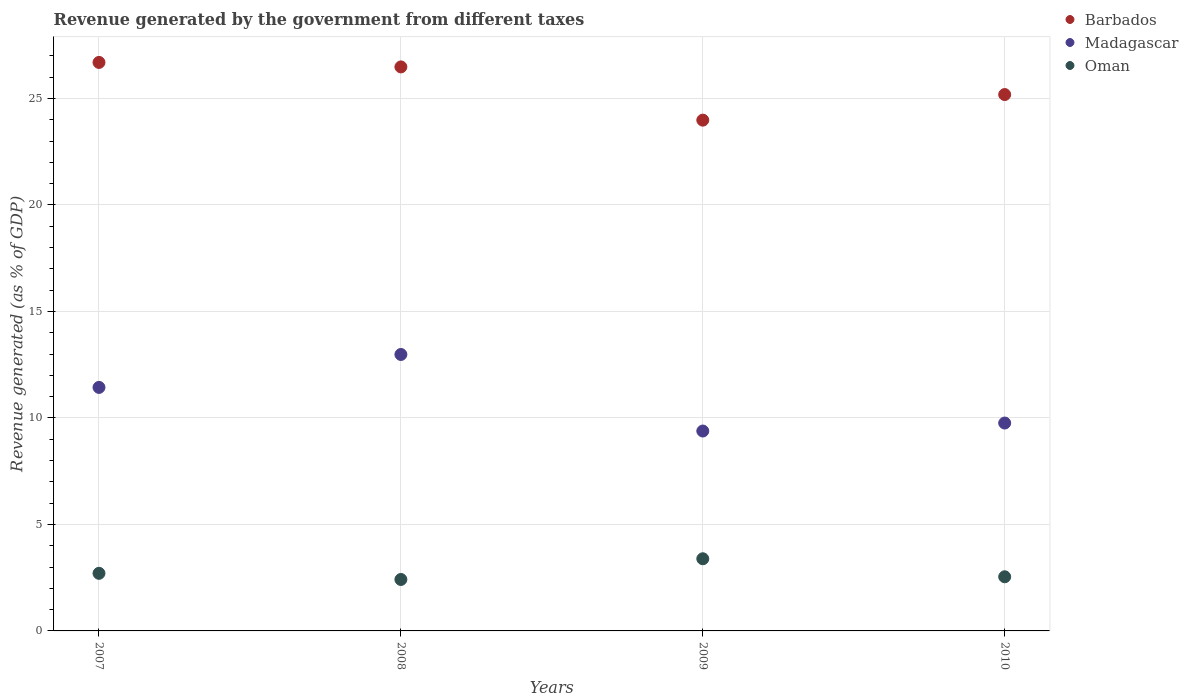How many different coloured dotlines are there?
Offer a very short reply. 3. Is the number of dotlines equal to the number of legend labels?
Offer a very short reply. Yes. What is the revenue generated by the government in Madagascar in 2007?
Your answer should be compact. 11.43. Across all years, what is the maximum revenue generated by the government in Oman?
Ensure brevity in your answer.  3.39. Across all years, what is the minimum revenue generated by the government in Barbados?
Provide a succinct answer. 23.98. In which year was the revenue generated by the government in Barbados maximum?
Provide a succinct answer. 2007. What is the total revenue generated by the government in Oman in the graph?
Provide a short and direct response. 11.05. What is the difference between the revenue generated by the government in Oman in 2008 and that in 2010?
Your answer should be compact. -0.13. What is the difference between the revenue generated by the government in Oman in 2008 and the revenue generated by the government in Madagascar in 2007?
Offer a very short reply. -9.02. What is the average revenue generated by the government in Madagascar per year?
Offer a very short reply. 10.89. In the year 2007, what is the difference between the revenue generated by the government in Madagascar and revenue generated by the government in Oman?
Keep it short and to the point. 8.73. What is the ratio of the revenue generated by the government in Madagascar in 2008 to that in 2009?
Offer a terse response. 1.38. What is the difference between the highest and the second highest revenue generated by the government in Oman?
Your answer should be very brief. 0.68. What is the difference between the highest and the lowest revenue generated by the government in Madagascar?
Provide a succinct answer. 3.59. Is it the case that in every year, the sum of the revenue generated by the government in Barbados and revenue generated by the government in Oman  is greater than the revenue generated by the government in Madagascar?
Keep it short and to the point. Yes. Does the revenue generated by the government in Madagascar monotonically increase over the years?
Keep it short and to the point. No. Is the revenue generated by the government in Oman strictly greater than the revenue generated by the government in Barbados over the years?
Keep it short and to the point. No. How many years are there in the graph?
Make the answer very short. 4. Where does the legend appear in the graph?
Keep it short and to the point. Top right. How are the legend labels stacked?
Your response must be concise. Vertical. What is the title of the graph?
Keep it short and to the point. Revenue generated by the government from different taxes. What is the label or title of the X-axis?
Provide a succinct answer. Years. What is the label or title of the Y-axis?
Keep it short and to the point. Revenue generated (as % of GDP). What is the Revenue generated (as % of GDP) of Barbados in 2007?
Make the answer very short. 26.69. What is the Revenue generated (as % of GDP) in Madagascar in 2007?
Make the answer very short. 11.43. What is the Revenue generated (as % of GDP) of Oman in 2007?
Offer a terse response. 2.7. What is the Revenue generated (as % of GDP) of Barbados in 2008?
Provide a short and direct response. 26.48. What is the Revenue generated (as % of GDP) of Madagascar in 2008?
Your answer should be very brief. 12.98. What is the Revenue generated (as % of GDP) in Oman in 2008?
Provide a succinct answer. 2.42. What is the Revenue generated (as % of GDP) of Barbados in 2009?
Offer a terse response. 23.98. What is the Revenue generated (as % of GDP) in Madagascar in 2009?
Give a very brief answer. 9.38. What is the Revenue generated (as % of GDP) in Oman in 2009?
Provide a short and direct response. 3.39. What is the Revenue generated (as % of GDP) of Barbados in 2010?
Make the answer very short. 25.18. What is the Revenue generated (as % of GDP) of Madagascar in 2010?
Give a very brief answer. 9.76. What is the Revenue generated (as % of GDP) in Oman in 2010?
Your response must be concise. 2.54. Across all years, what is the maximum Revenue generated (as % of GDP) of Barbados?
Your answer should be compact. 26.69. Across all years, what is the maximum Revenue generated (as % of GDP) in Madagascar?
Offer a very short reply. 12.98. Across all years, what is the maximum Revenue generated (as % of GDP) of Oman?
Your answer should be compact. 3.39. Across all years, what is the minimum Revenue generated (as % of GDP) of Barbados?
Provide a succinct answer. 23.98. Across all years, what is the minimum Revenue generated (as % of GDP) of Madagascar?
Make the answer very short. 9.38. Across all years, what is the minimum Revenue generated (as % of GDP) of Oman?
Your response must be concise. 2.42. What is the total Revenue generated (as % of GDP) in Barbados in the graph?
Keep it short and to the point. 102.33. What is the total Revenue generated (as % of GDP) in Madagascar in the graph?
Make the answer very short. 43.56. What is the total Revenue generated (as % of GDP) in Oman in the graph?
Keep it short and to the point. 11.05. What is the difference between the Revenue generated (as % of GDP) in Barbados in 2007 and that in 2008?
Provide a short and direct response. 0.21. What is the difference between the Revenue generated (as % of GDP) in Madagascar in 2007 and that in 2008?
Offer a terse response. -1.55. What is the difference between the Revenue generated (as % of GDP) in Oman in 2007 and that in 2008?
Provide a short and direct response. 0.29. What is the difference between the Revenue generated (as % of GDP) in Barbados in 2007 and that in 2009?
Your answer should be very brief. 2.71. What is the difference between the Revenue generated (as % of GDP) in Madagascar in 2007 and that in 2009?
Offer a very short reply. 2.05. What is the difference between the Revenue generated (as % of GDP) of Oman in 2007 and that in 2009?
Give a very brief answer. -0.68. What is the difference between the Revenue generated (as % of GDP) in Barbados in 2007 and that in 2010?
Offer a very short reply. 1.51. What is the difference between the Revenue generated (as % of GDP) of Madagascar in 2007 and that in 2010?
Give a very brief answer. 1.67. What is the difference between the Revenue generated (as % of GDP) of Oman in 2007 and that in 2010?
Offer a terse response. 0.16. What is the difference between the Revenue generated (as % of GDP) in Barbados in 2008 and that in 2009?
Offer a very short reply. 2.5. What is the difference between the Revenue generated (as % of GDP) in Madagascar in 2008 and that in 2009?
Provide a succinct answer. 3.59. What is the difference between the Revenue generated (as % of GDP) of Oman in 2008 and that in 2009?
Your answer should be very brief. -0.97. What is the difference between the Revenue generated (as % of GDP) in Barbados in 2008 and that in 2010?
Your answer should be compact. 1.3. What is the difference between the Revenue generated (as % of GDP) in Madagascar in 2008 and that in 2010?
Give a very brief answer. 3.22. What is the difference between the Revenue generated (as % of GDP) in Oman in 2008 and that in 2010?
Give a very brief answer. -0.13. What is the difference between the Revenue generated (as % of GDP) of Barbados in 2009 and that in 2010?
Your response must be concise. -1.2. What is the difference between the Revenue generated (as % of GDP) in Madagascar in 2009 and that in 2010?
Your response must be concise. -0.38. What is the difference between the Revenue generated (as % of GDP) in Oman in 2009 and that in 2010?
Give a very brief answer. 0.85. What is the difference between the Revenue generated (as % of GDP) in Barbados in 2007 and the Revenue generated (as % of GDP) in Madagascar in 2008?
Offer a terse response. 13.71. What is the difference between the Revenue generated (as % of GDP) of Barbados in 2007 and the Revenue generated (as % of GDP) of Oman in 2008?
Keep it short and to the point. 24.28. What is the difference between the Revenue generated (as % of GDP) in Madagascar in 2007 and the Revenue generated (as % of GDP) in Oman in 2008?
Provide a short and direct response. 9.02. What is the difference between the Revenue generated (as % of GDP) in Barbados in 2007 and the Revenue generated (as % of GDP) in Madagascar in 2009?
Give a very brief answer. 17.31. What is the difference between the Revenue generated (as % of GDP) in Barbados in 2007 and the Revenue generated (as % of GDP) in Oman in 2009?
Your answer should be compact. 23.3. What is the difference between the Revenue generated (as % of GDP) in Madagascar in 2007 and the Revenue generated (as % of GDP) in Oman in 2009?
Your answer should be very brief. 8.05. What is the difference between the Revenue generated (as % of GDP) of Barbados in 2007 and the Revenue generated (as % of GDP) of Madagascar in 2010?
Offer a terse response. 16.93. What is the difference between the Revenue generated (as % of GDP) in Barbados in 2007 and the Revenue generated (as % of GDP) in Oman in 2010?
Provide a succinct answer. 24.15. What is the difference between the Revenue generated (as % of GDP) of Madagascar in 2007 and the Revenue generated (as % of GDP) of Oman in 2010?
Give a very brief answer. 8.89. What is the difference between the Revenue generated (as % of GDP) in Barbados in 2008 and the Revenue generated (as % of GDP) in Madagascar in 2009?
Offer a terse response. 17.1. What is the difference between the Revenue generated (as % of GDP) in Barbados in 2008 and the Revenue generated (as % of GDP) in Oman in 2009?
Your response must be concise. 23.09. What is the difference between the Revenue generated (as % of GDP) in Madagascar in 2008 and the Revenue generated (as % of GDP) in Oman in 2009?
Your response must be concise. 9.59. What is the difference between the Revenue generated (as % of GDP) of Barbados in 2008 and the Revenue generated (as % of GDP) of Madagascar in 2010?
Provide a short and direct response. 16.72. What is the difference between the Revenue generated (as % of GDP) of Barbados in 2008 and the Revenue generated (as % of GDP) of Oman in 2010?
Ensure brevity in your answer.  23.94. What is the difference between the Revenue generated (as % of GDP) of Madagascar in 2008 and the Revenue generated (as % of GDP) of Oman in 2010?
Provide a succinct answer. 10.44. What is the difference between the Revenue generated (as % of GDP) of Barbados in 2009 and the Revenue generated (as % of GDP) of Madagascar in 2010?
Offer a very short reply. 14.22. What is the difference between the Revenue generated (as % of GDP) of Barbados in 2009 and the Revenue generated (as % of GDP) of Oman in 2010?
Offer a very short reply. 21.44. What is the difference between the Revenue generated (as % of GDP) in Madagascar in 2009 and the Revenue generated (as % of GDP) in Oman in 2010?
Your response must be concise. 6.84. What is the average Revenue generated (as % of GDP) of Barbados per year?
Offer a very short reply. 25.58. What is the average Revenue generated (as % of GDP) of Madagascar per year?
Your answer should be very brief. 10.89. What is the average Revenue generated (as % of GDP) of Oman per year?
Offer a very short reply. 2.76. In the year 2007, what is the difference between the Revenue generated (as % of GDP) in Barbados and Revenue generated (as % of GDP) in Madagascar?
Keep it short and to the point. 15.26. In the year 2007, what is the difference between the Revenue generated (as % of GDP) in Barbados and Revenue generated (as % of GDP) in Oman?
Provide a short and direct response. 23.99. In the year 2007, what is the difference between the Revenue generated (as % of GDP) in Madagascar and Revenue generated (as % of GDP) in Oman?
Provide a short and direct response. 8.73. In the year 2008, what is the difference between the Revenue generated (as % of GDP) in Barbados and Revenue generated (as % of GDP) in Madagascar?
Offer a very short reply. 13.5. In the year 2008, what is the difference between the Revenue generated (as % of GDP) in Barbados and Revenue generated (as % of GDP) in Oman?
Ensure brevity in your answer.  24.06. In the year 2008, what is the difference between the Revenue generated (as % of GDP) of Madagascar and Revenue generated (as % of GDP) of Oman?
Offer a very short reply. 10.56. In the year 2009, what is the difference between the Revenue generated (as % of GDP) in Barbados and Revenue generated (as % of GDP) in Madagascar?
Make the answer very short. 14.6. In the year 2009, what is the difference between the Revenue generated (as % of GDP) in Barbados and Revenue generated (as % of GDP) in Oman?
Make the answer very short. 20.59. In the year 2009, what is the difference between the Revenue generated (as % of GDP) in Madagascar and Revenue generated (as % of GDP) in Oman?
Provide a short and direct response. 6. In the year 2010, what is the difference between the Revenue generated (as % of GDP) of Barbados and Revenue generated (as % of GDP) of Madagascar?
Make the answer very short. 15.42. In the year 2010, what is the difference between the Revenue generated (as % of GDP) in Barbados and Revenue generated (as % of GDP) in Oman?
Your answer should be very brief. 22.64. In the year 2010, what is the difference between the Revenue generated (as % of GDP) of Madagascar and Revenue generated (as % of GDP) of Oman?
Provide a short and direct response. 7.22. What is the ratio of the Revenue generated (as % of GDP) in Barbados in 2007 to that in 2008?
Give a very brief answer. 1.01. What is the ratio of the Revenue generated (as % of GDP) of Madagascar in 2007 to that in 2008?
Your answer should be compact. 0.88. What is the ratio of the Revenue generated (as % of GDP) in Oman in 2007 to that in 2008?
Offer a terse response. 1.12. What is the ratio of the Revenue generated (as % of GDP) of Barbados in 2007 to that in 2009?
Give a very brief answer. 1.11. What is the ratio of the Revenue generated (as % of GDP) of Madagascar in 2007 to that in 2009?
Provide a short and direct response. 1.22. What is the ratio of the Revenue generated (as % of GDP) of Oman in 2007 to that in 2009?
Your response must be concise. 0.8. What is the ratio of the Revenue generated (as % of GDP) of Barbados in 2007 to that in 2010?
Your answer should be very brief. 1.06. What is the ratio of the Revenue generated (as % of GDP) of Madagascar in 2007 to that in 2010?
Provide a succinct answer. 1.17. What is the ratio of the Revenue generated (as % of GDP) in Oman in 2007 to that in 2010?
Give a very brief answer. 1.06. What is the ratio of the Revenue generated (as % of GDP) of Barbados in 2008 to that in 2009?
Provide a short and direct response. 1.1. What is the ratio of the Revenue generated (as % of GDP) of Madagascar in 2008 to that in 2009?
Offer a terse response. 1.38. What is the ratio of the Revenue generated (as % of GDP) of Oman in 2008 to that in 2009?
Offer a terse response. 0.71. What is the ratio of the Revenue generated (as % of GDP) in Barbados in 2008 to that in 2010?
Ensure brevity in your answer.  1.05. What is the ratio of the Revenue generated (as % of GDP) in Madagascar in 2008 to that in 2010?
Offer a very short reply. 1.33. What is the ratio of the Revenue generated (as % of GDP) in Oman in 2008 to that in 2010?
Provide a short and direct response. 0.95. What is the ratio of the Revenue generated (as % of GDP) of Barbados in 2009 to that in 2010?
Offer a very short reply. 0.95. What is the ratio of the Revenue generated (as % of GDP) of Madagascar in 2009 to that in 2010?
Provide a short and direct response. 0.96. What is the ratio of the Revenue generated (as % of GDP) in Oman in 2009 to that in 2010?
Ensure brevity in your answer.  1.33. What is the difference between the highest and the second highest Revenue generated (as % of GDP) of Barbados?
Give a very brief answer. 0.21. What is the difference between the highest and the second highest Revenue generated (as % of GDP) of Madagascar?
Offer a terse response. 1.55. What is the difference between the highest and the second highest Revenue generated (as % of GDP) in Oman?
Provide a short and direct response. 0.68. What is the difference between the highest and the lowest Revenue generated (as % of GDP) in Barbados?
Provide a succinct answer. 2.71. What is the difference between the highest and the lowest Revenue generated (as % of GDP) in Madagascar?
Keep it short and to the point. 3.59. What is the difference between the highest and the lowest Revenue generated (as % of GDP) in Oman?
Provide a succinct answer. 0.97. 